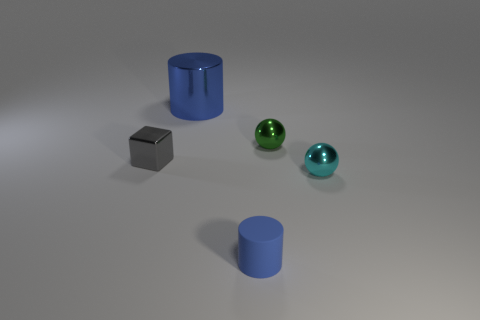Is there any other thing that has the same material as the tiny blue thing?
Your answer should be compact. No. Do the cylinder that is behind the green metal ball and the cyan thing have the same material?
Provide a succinct answer. Yes. There is a gray metal object that is to the left of the ball in front of the object that is left of the big object; what size is it?
Make the answer very short. Small. How many other things are there of the same color as the large metallic cylinder?
Provide a short and direct response. 1. What shape is the green metal thing that is the same size as the cyan object?
Provide a succinct answer. Sphere. How big is the gray metal thing on the left side of the blue metal cylinder?
Keep it short and to the point. Small. Does the tiny metallic ball that is in front of the gray cube have the same color as the cylinder that is behind the tiny rubber object?
Your response must be concise. No. The cylinder that is to the right of the blue thing that is left of the blue thing that is to the right of the blue metal cylinder is made of what material?
Offer a terse response. Rubber. Are there any blue spheres that have the same size as the green thing?
Offer a very short reply. No. What is the material of the cube that is the same size as the green thing?
Ensure brevity in your answer.  Metal. 